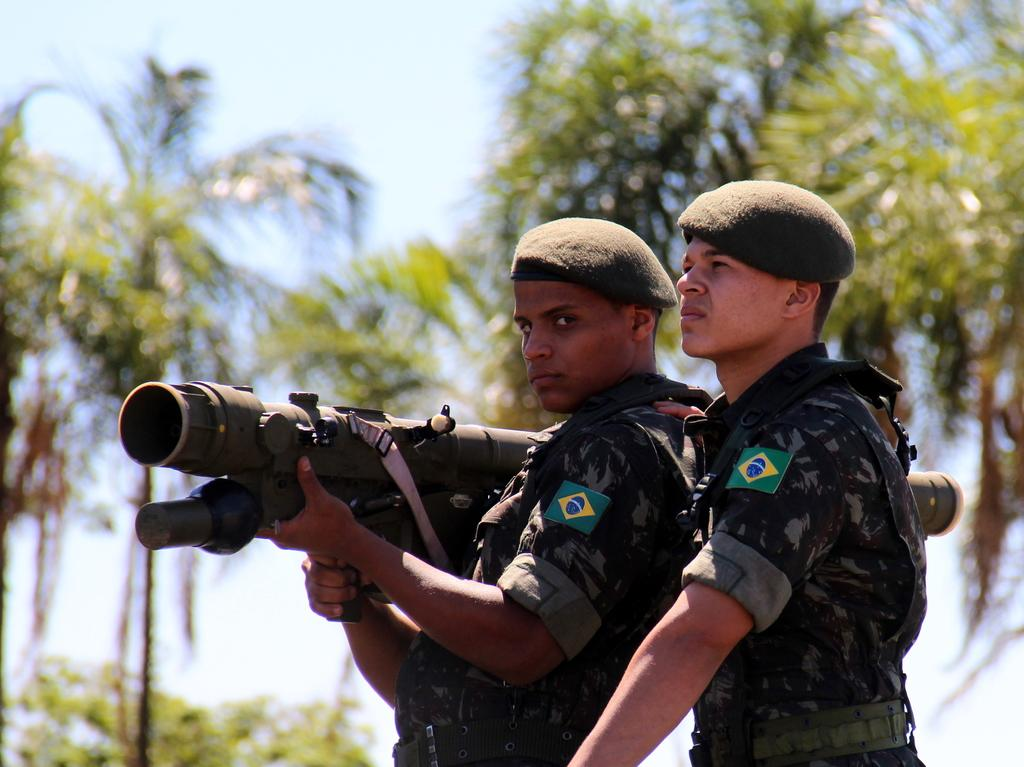How many people are in the image? There are two men in the image. What are the men doing in the image? The men are standing in the image. What are the men wearing? The men are wearing uniforms in the image. What can be seen in the background of the image? There are green color trees in the background of the image. What is visible at the top of the image? The sky is visible at the top of the image. What type of seed can be seen growing in the hall in the image? There is no seed or hall present in the image; it features two men standing in front of green trees and the sky. 